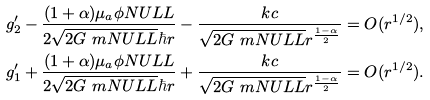Convert formula to latex. <formula><loc_0><loc_0><loc_500><loc_500>& g _ { 2 } ^ { \prime } - \frac { ( 1 + \alpha ) \mu _ { a } \phi N U L L } { 2 \sqrt { 2 G \ m N U L L } \hbar { r } } - \frac { k c } { \sqrt { 2 G \ m N U L L } r ^ { \frac { 1 - \alpha } { 2 } } } = O ( r ^ { 1 / 2 } ) , \\ & g _ { 1 } ^ { \prime } + \frac { ( 1 + \alpha ) \mu _ { a } \phi N U L L } { 2 \sqrt { 2 G \ m N U L L } \hbar { r } } + \frac { k c } { \sqrt { 2 G \ m N U L L } r ^ { \frac { 1 - \alpha } { 2 } } } = O ( r ^ { 1 / 2 } ) .</formula> 